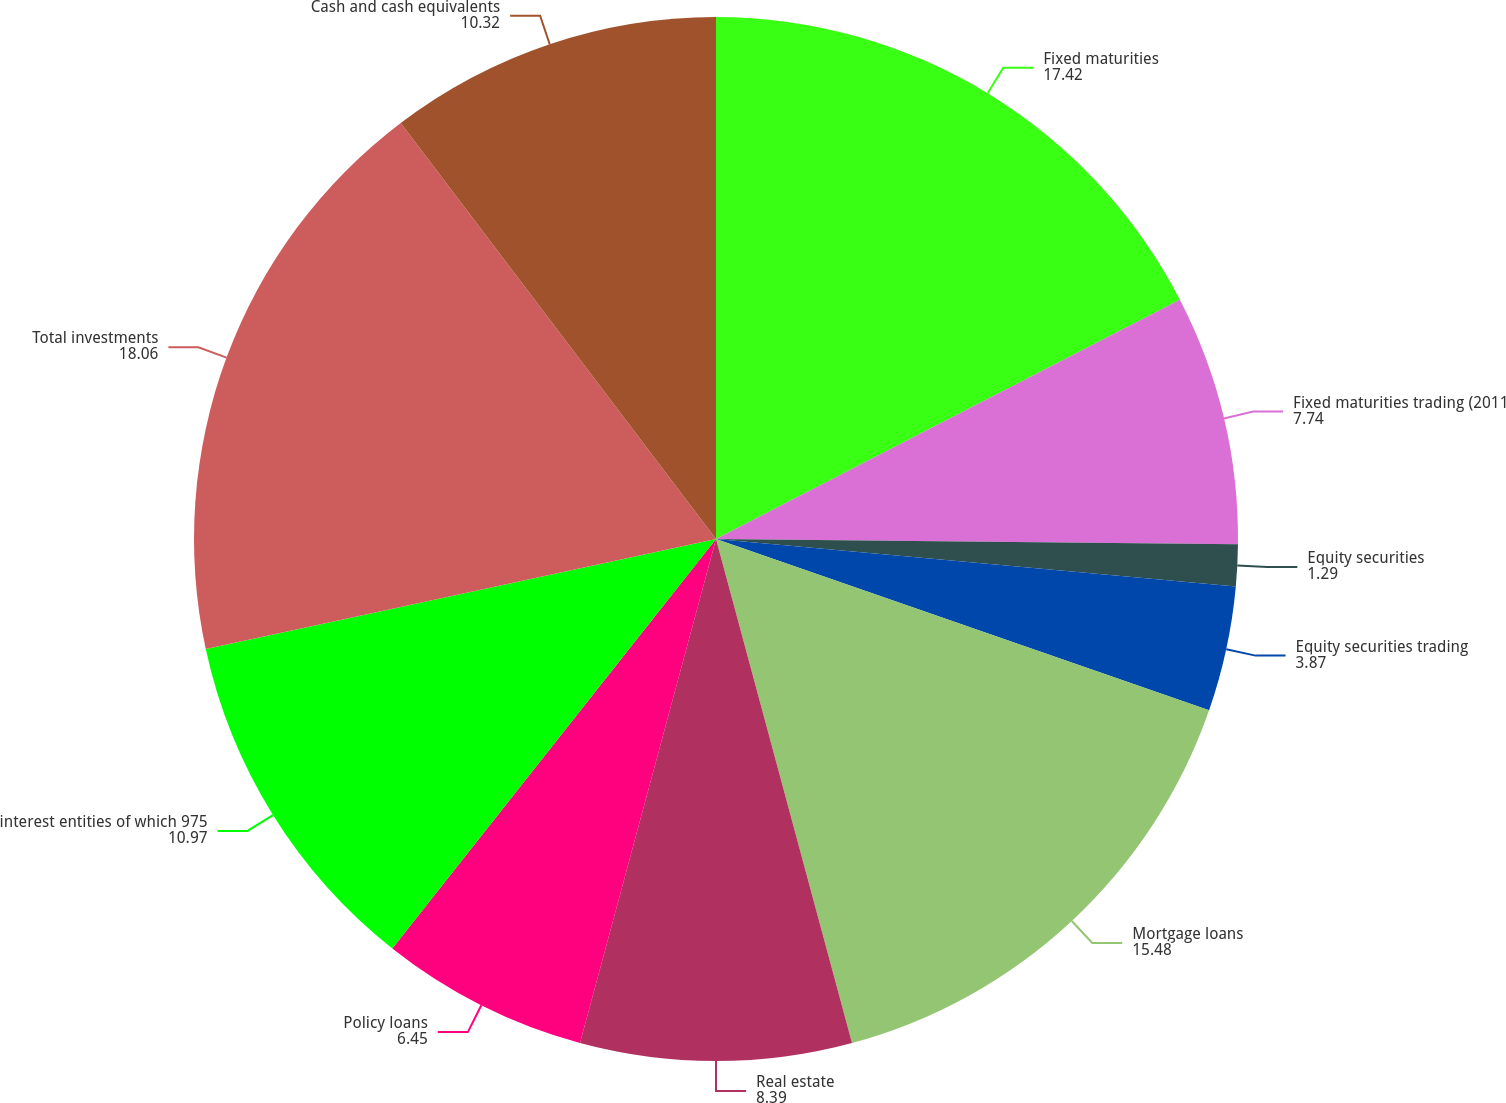Convert chart. <chart><loc_0><loc_0><loc_500><loc_500><pie_chart><fcel>Fixed maturities<fcel>Fixed maturities trading (2011<fcel>Equity securities<fcel>Equity securities trading<fcel>Mortgage loans<fcel>Real estate<fcel>Policy loans<fcel>interest entities of which 975<fcel>Total investments<fcel>Cash and cash equivalents<nl><fcel>17.42%<fcel>7.74%<fcel>1.29%<fcel>3.87%<fcel>15.48%<fcel>8.39%<fcel>6.45%<fcel>10.97%<fcel>18.06%<fcel>10.32%<nl></chart> 